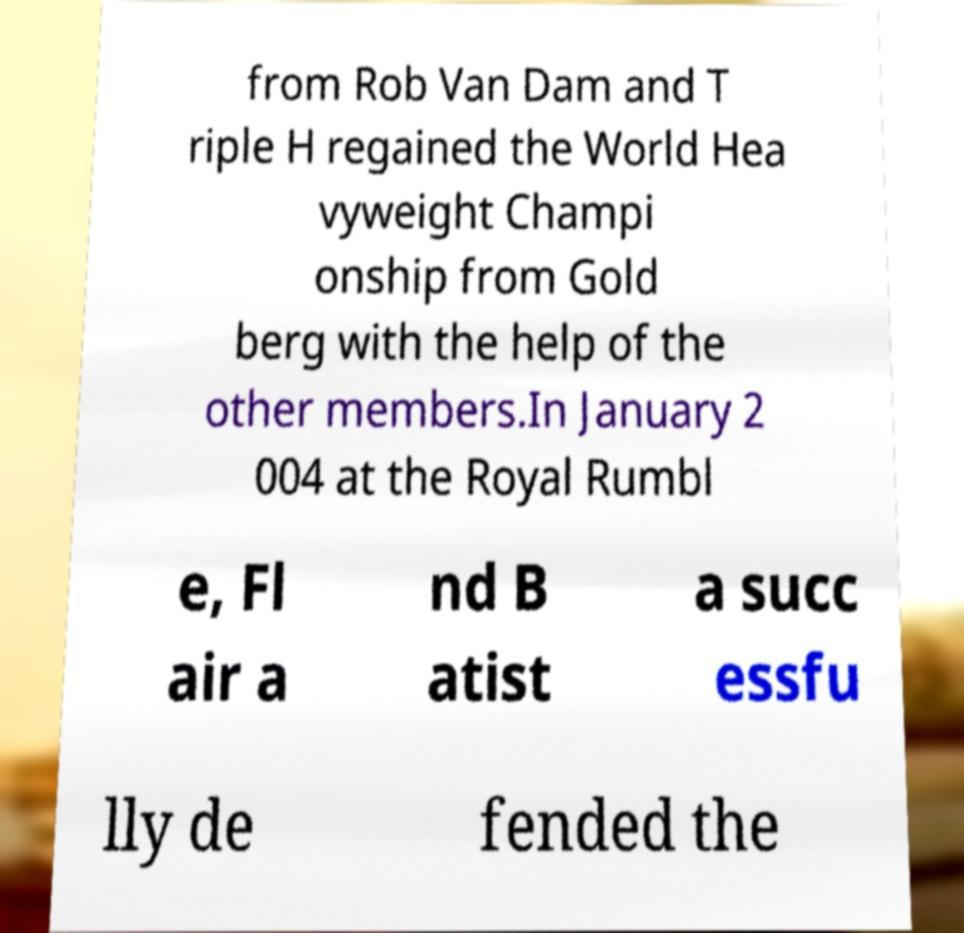Please identify and transcribe the text found in this image. from Rob Van Dam and T riple H regained the World Hea vyweight Champi onship from Gold berg with the help of the other members.In January 2 004 at the Royal Rumbl e, Fl air a nd B atist a succ essfu lly de fended the 